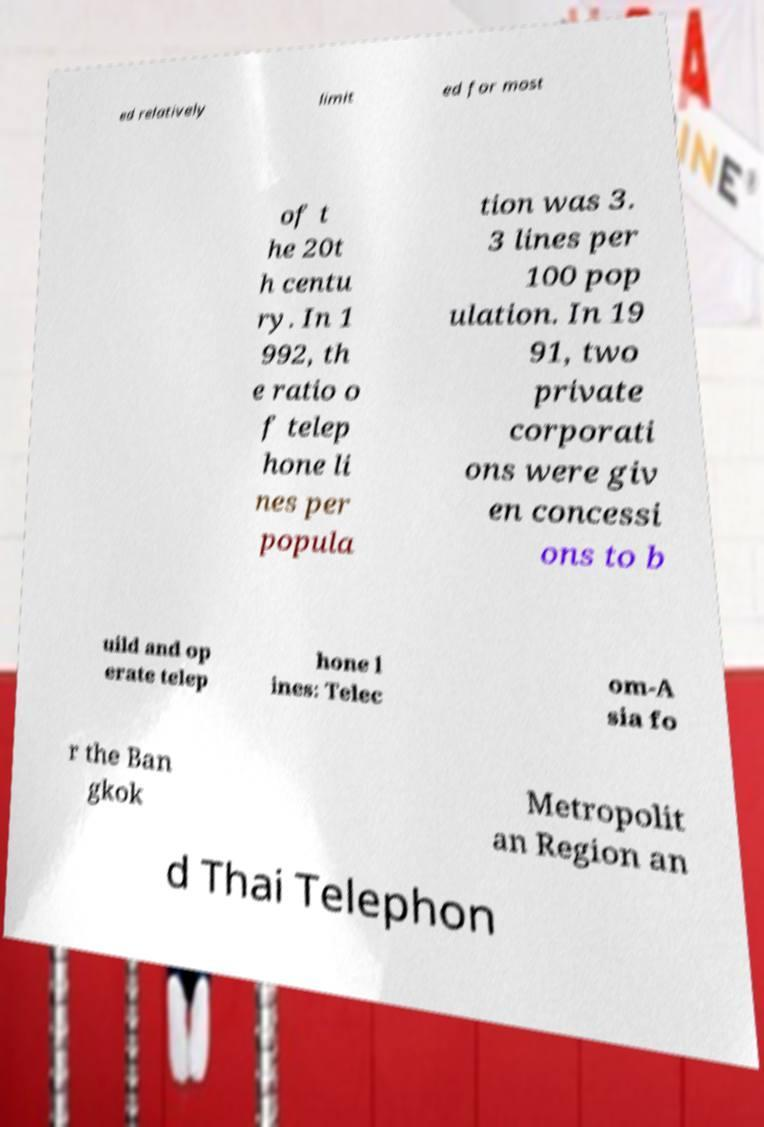Could you extract and type out the text from this image? ed relatively limit ed for most of t he 20t h centu ry. In 1 992, th e ratio o f telep hone li nes per popula tion was 3. 3 lines per 100 pop ulation. In 19 91, two private corporati ons were giv en concessi ons to b uild and op erate telep hone l ines: Telec om-A sia fo r the Ban gkok Metropolit an Region an d Thai Telephon 